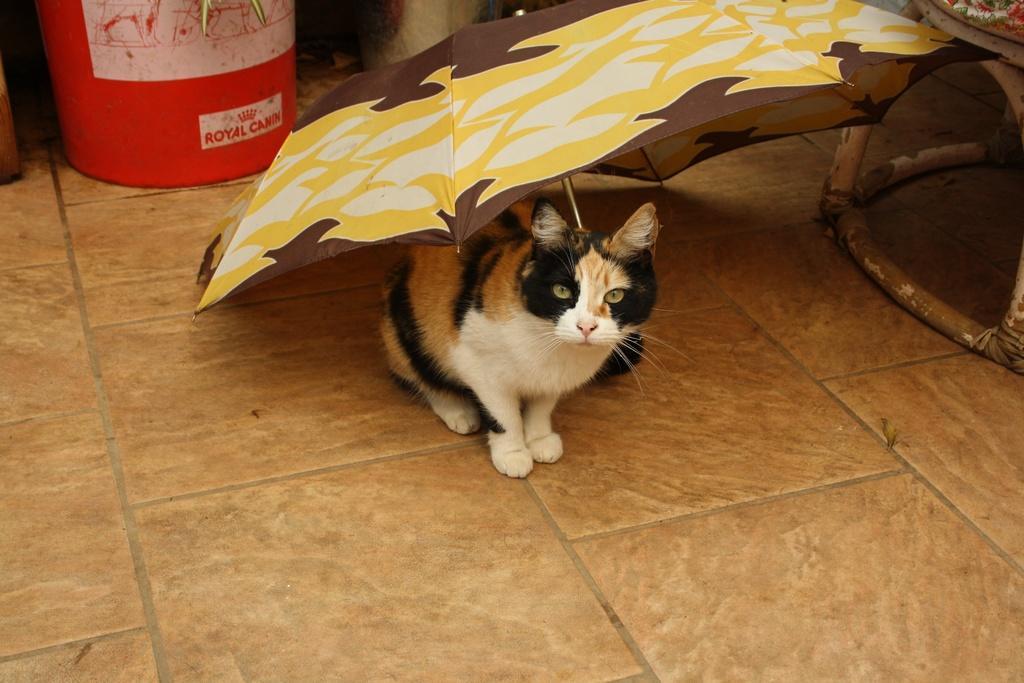Please provide a concise description of this image. In this picture, we can see the ground and some objects on the ground like umbrella, container, and we can see an animal on the ground. 